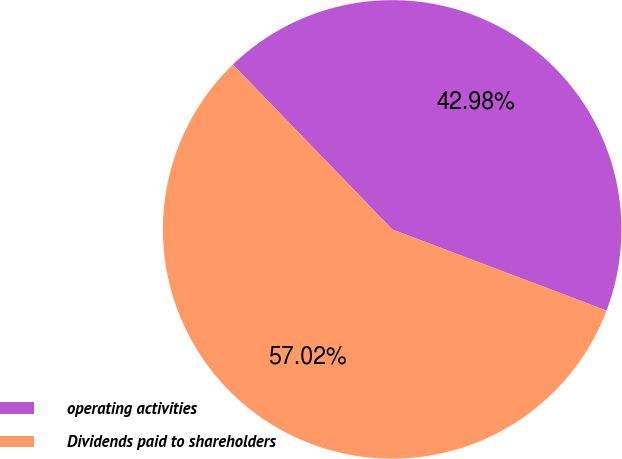Convert chart to OTSL. <chart><loc_0><loc_0><loc_500><loc_500><pie_chart><fcel>operating activities<fcel>Dividends paid to shareholders<nl><fcel>42.98%<fcel>57.02%<nl></chart> 